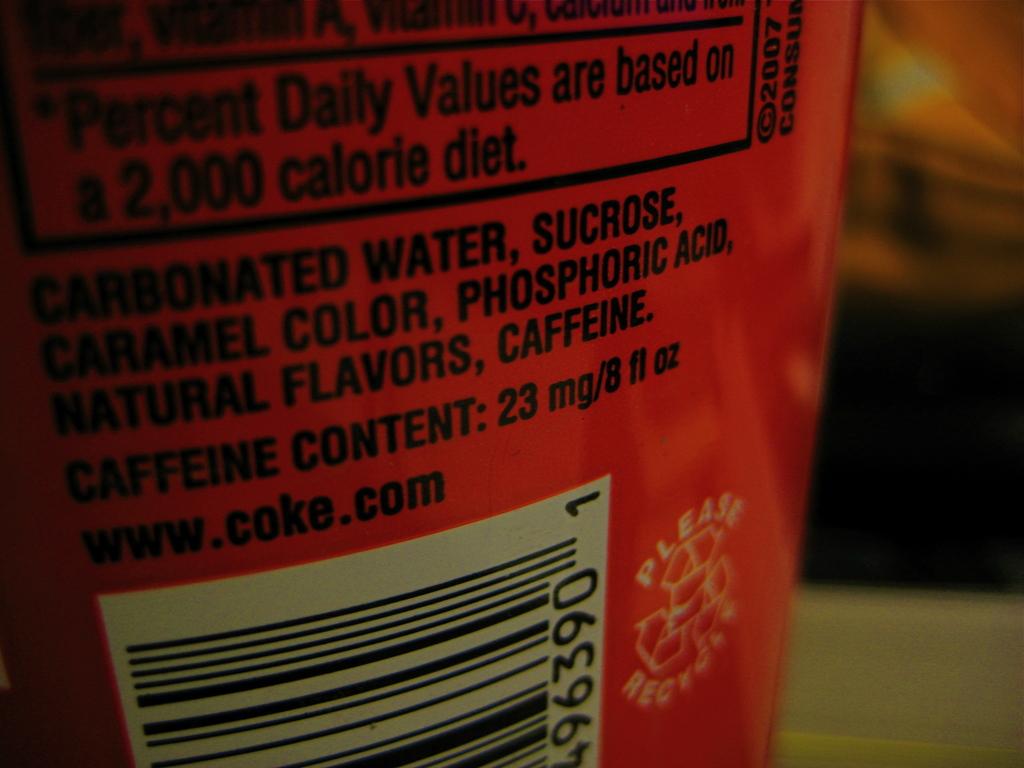What are the ingredients?
Offer a very short reply. Carbonated water, sucrose, caramel color, phosphoric acid, natural flavors, caffeine. What is the website at the bottom?
Make the answer very short. Www.coke.com. 